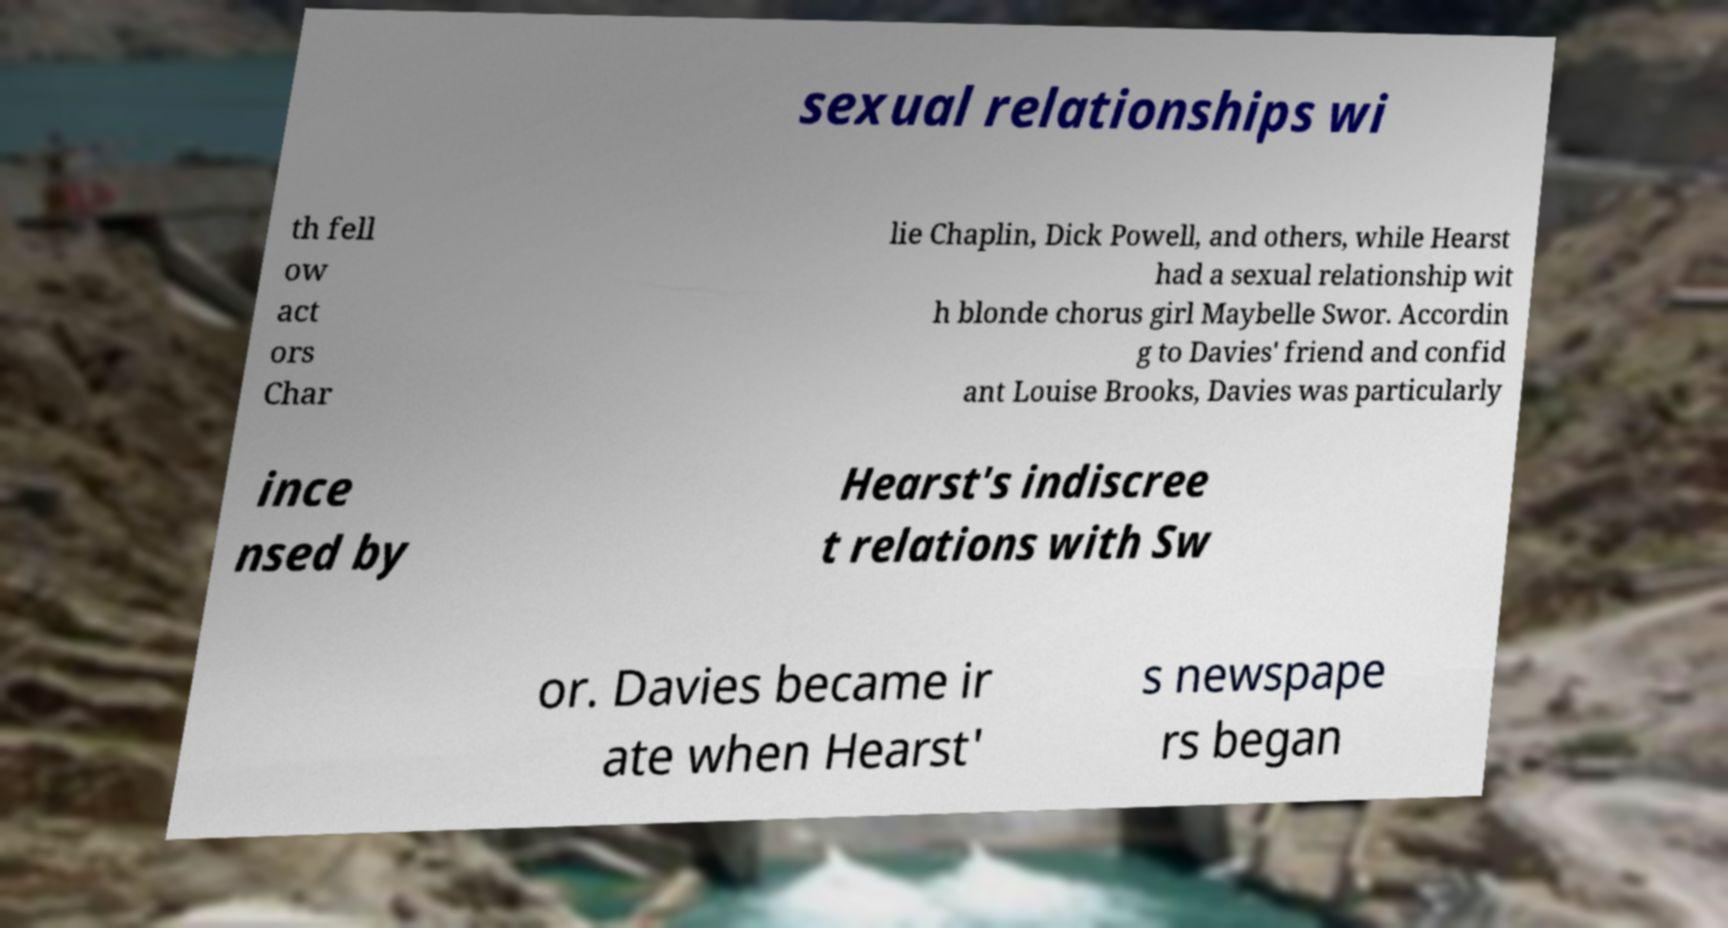For documentation purposes, I need the text within this image transcribed. Could you provide that? sexual relationships wi th fell ow act ors Char lie Chaplin, Dick Powell, and others, while Hearst had a sexual relationship wit h blonde chorus girl Maybelle Swor. Accordin g to Davies' friend and confid ant Louise Brooks, Davies was particularly ince nsed by Hearst's indiscree t relations with Sw or. Davies became ir ate when Hearst' s newspape rs began 